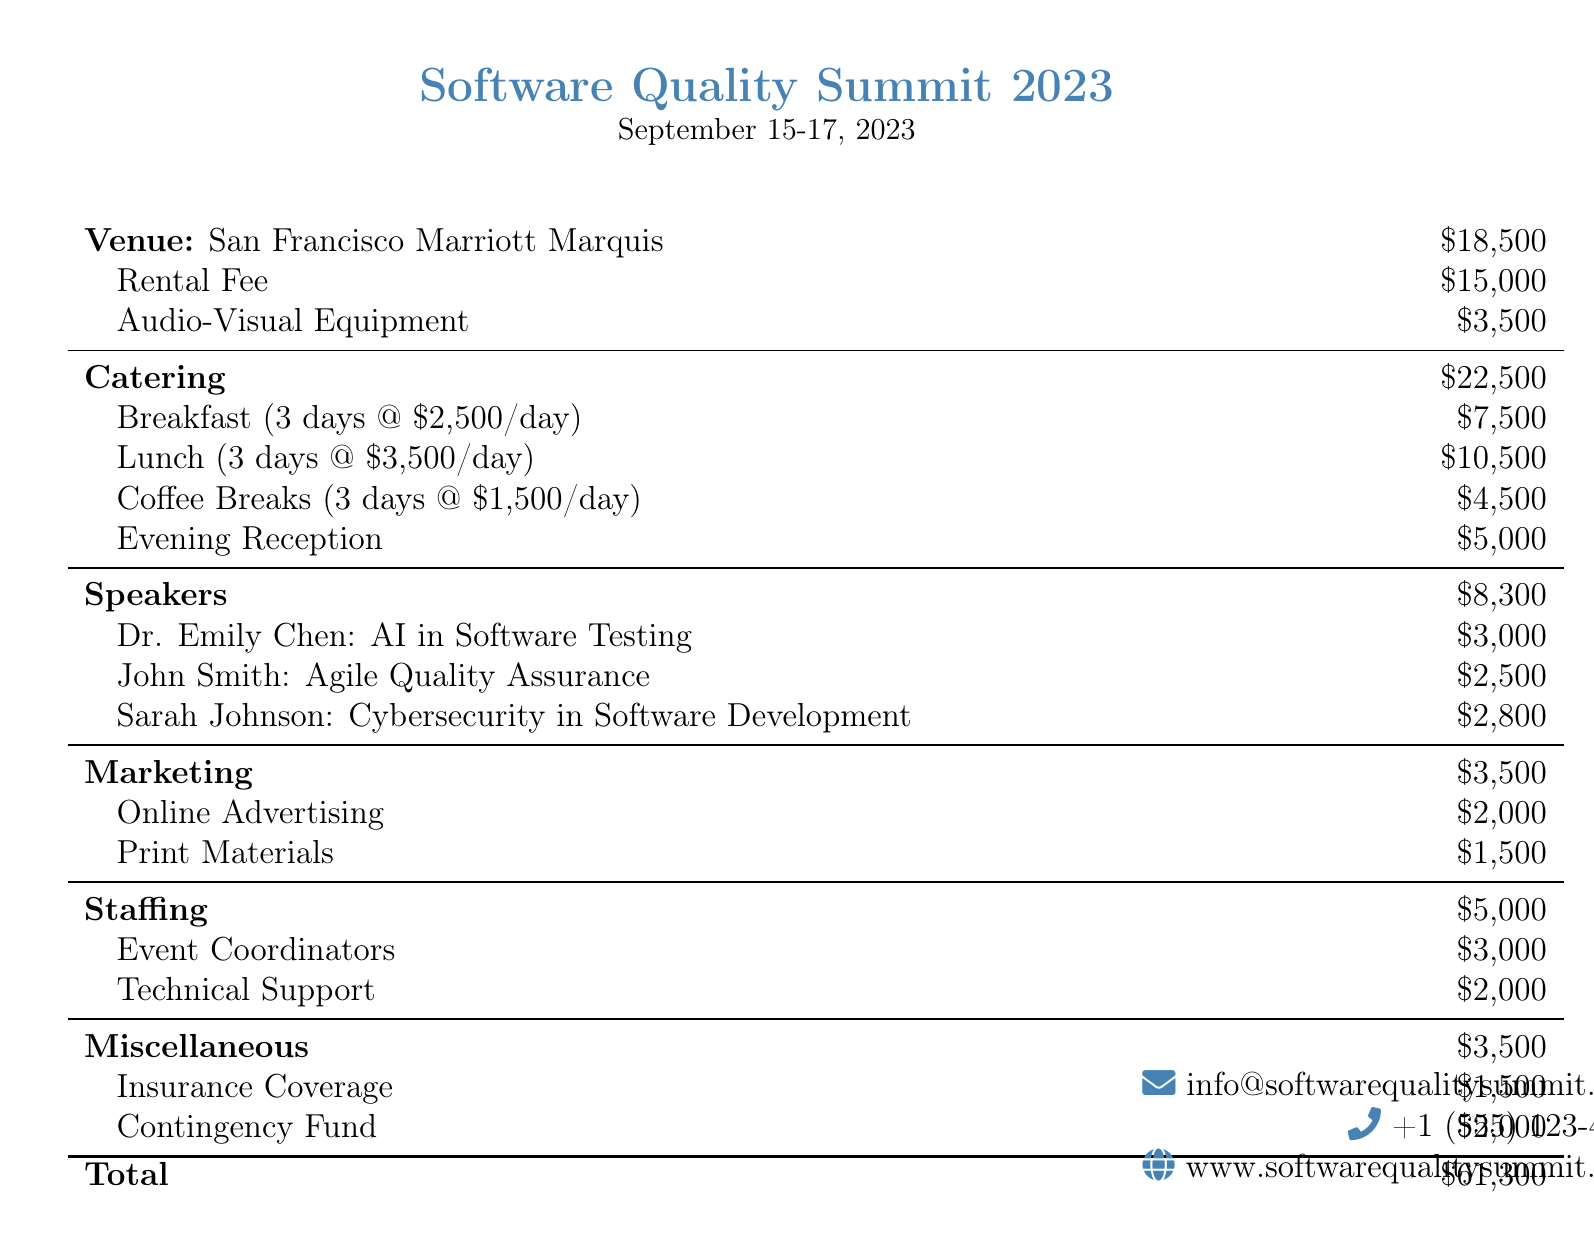What is the total cost for the venue? The total cost for the venue is the sum of the rental fee and audio-visual equipment costs.
Answer: $18,500 How much is the breakfast catering cost? The breakfast catering cost is listed as three days at $2,500 per day.
Answer: $7,500 Who is speaking about Agile Quality Assurance? The document lists speakers along with their topics, and John Smith is associated with Agile Quality Assurance.
Answer: John Smith What is the cost of speaker fees? The total cost for all speakers is calculated by adding the individual fees listed for each speaker.
Answer: $8,300 How much is allocated for marketing? The document specifies a budget line for marketing expenses, detailing its total amount.
Answer: $3,500 What is the cost for evening reception catering? The evening reception is a specific line item under catering with its own listed cost.
Answer: $5,000 What portion of the budget is designated for staffing? Staffing costs are explicitly listed as a separate category within the document.
Answer: $5,000 What is the total amount of the bill? The total amount combines all the separate categories' expenses documented, concluding with the final figure.
Answer: $61,300 What is included in the miscellaneous costs? The miscellaneous section details two items: insurance coverage and a contingency fund.
Answer: $3,500 